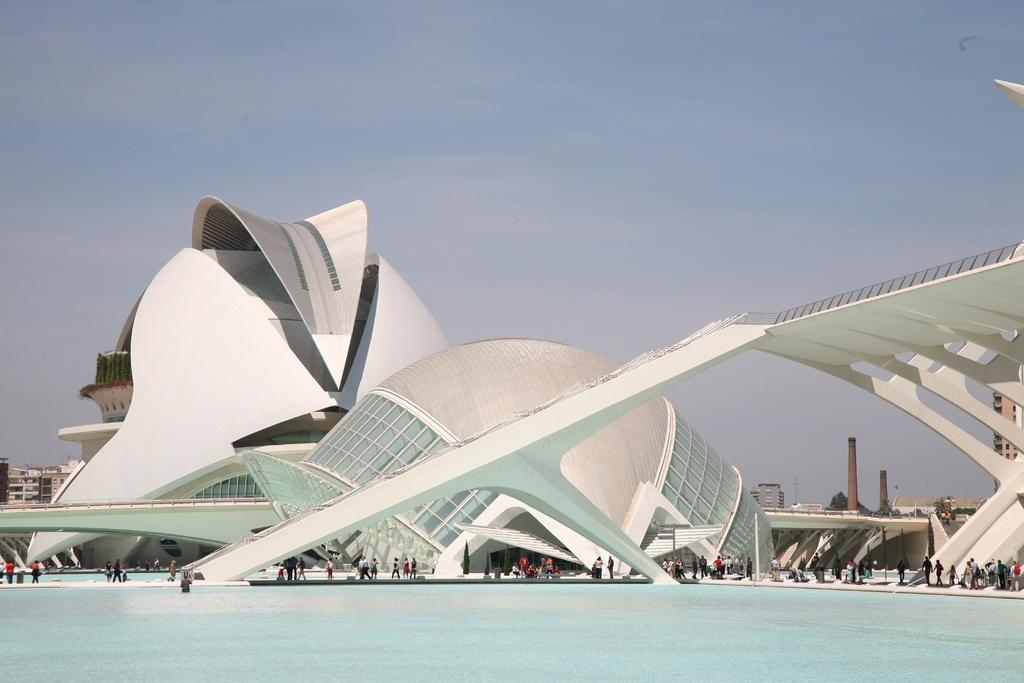What type of structures can be seen in the image? There are buildings and a tower in the image. Where are the people located in the image? The group of people is standing beside a water body in the image. What other natural elements can be seen in the image? There are trees in the image. How would you describe the sky in the image? The sky is visible in the image and appears cloudy. What word is being used by the trees in the image? There are no words being used by the trees in the image. 